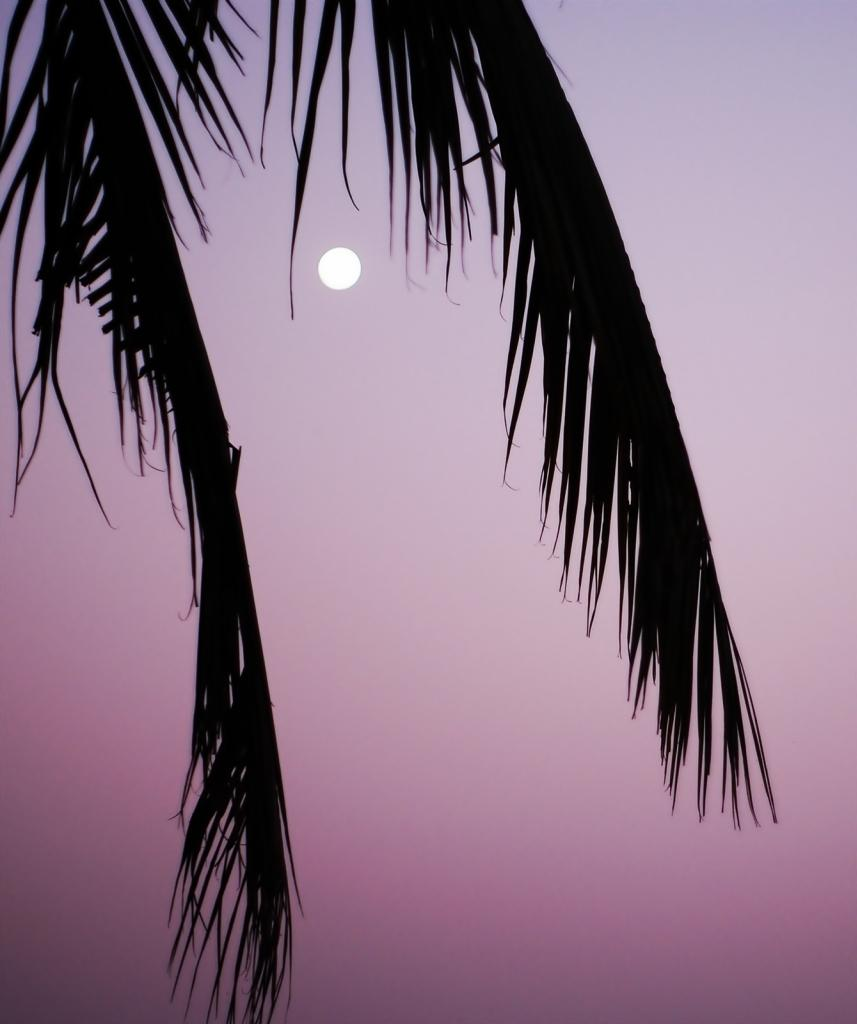What type of natural elements can be seen in the image? There are tree leaves in the image. What celestial body is visible in the image? There is a moon visible in the image. How would you describe the sky in the background of the image? The sky in the background is colorful. What type of teaching method is being demonstrated in the image? There is no teaching method or activity present in the image. Can you see a receipt for any purchases in the image? There is no receipt visible in the image. 